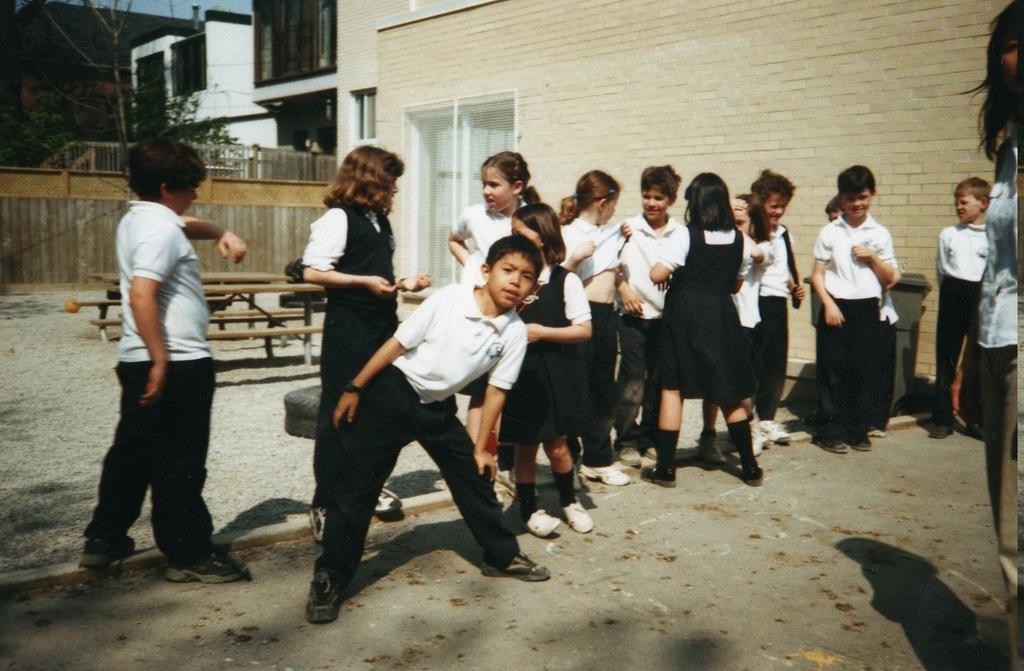In one or two sentences, can you explain what this image depicts? In this picture we can see some kids are standing, in the background there are some buildings, we can see benches in the middle, at the bottom there are some stones, on the left side there is a tree. 